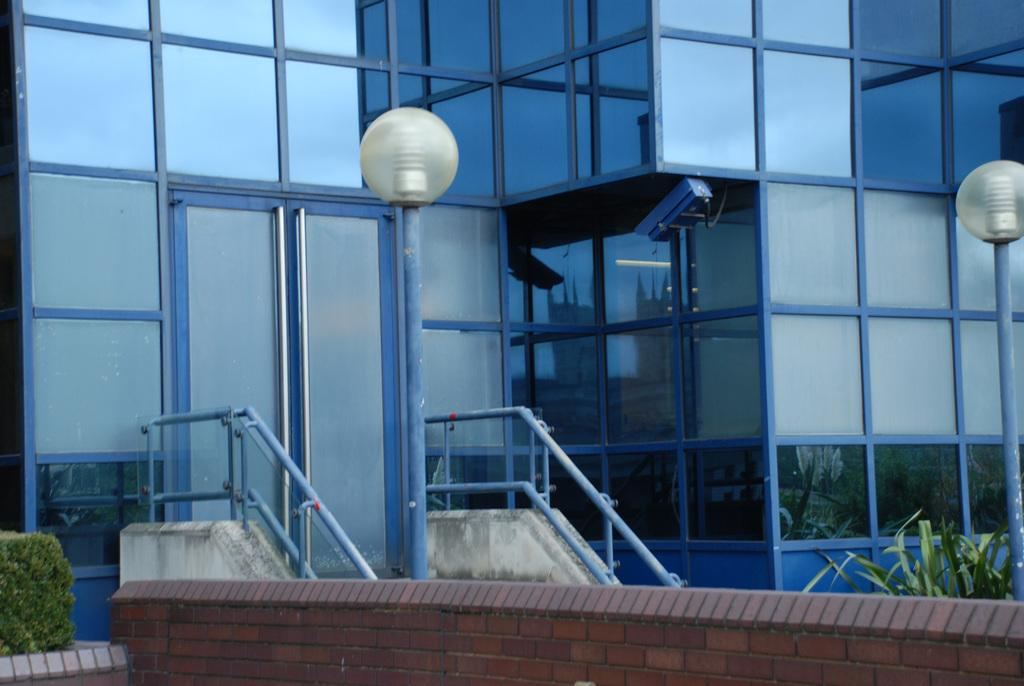What is located at the bottom of the image? There are plants and a wall at the bottom of the image. What can be seen in the background of the image? There are lights, stairs, and a building visible in the background. What is your son doing in the image? There is no reference to a son or any person in the image, so it's not possible to answer that question. 